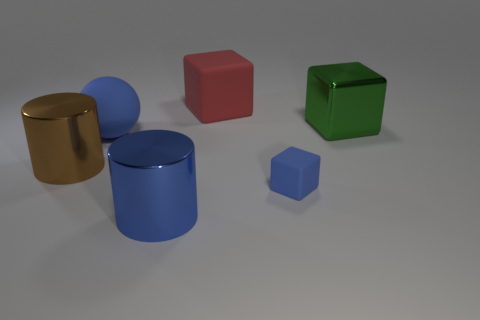Subtract all metallic cubes. How many cubes are left? 2 Add 4 large brown cylinders. How many objects exist? 10 Subtract 1 blue balls. How many objects are left? 5 Subtract all cylinders. How many objects are left? 4 Subtract 2 cylinders. How many cylinders are left? 0 Subtract all blue cylinders. Subtract all gray cubes. How many cylinders are left? 1 Subtract all purple cylinders. How many cyan blocks are left? 0 Subtract all big purple metal cylinders. Subtract all big shiny objects. How many objects are left? 3 Add 3 tiny blue matte cubes. How many tiny blue matte cubes are left? 4 Add 1 big green matte cubes. How many big green matte cubes exist? 1 